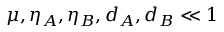<formula> <loc_0><loc_0><loc_500><loc_500>\mu , \eta _ { A } , \eta _ { B } , d _ { A } , d _ { B } \ll 1</formula> 